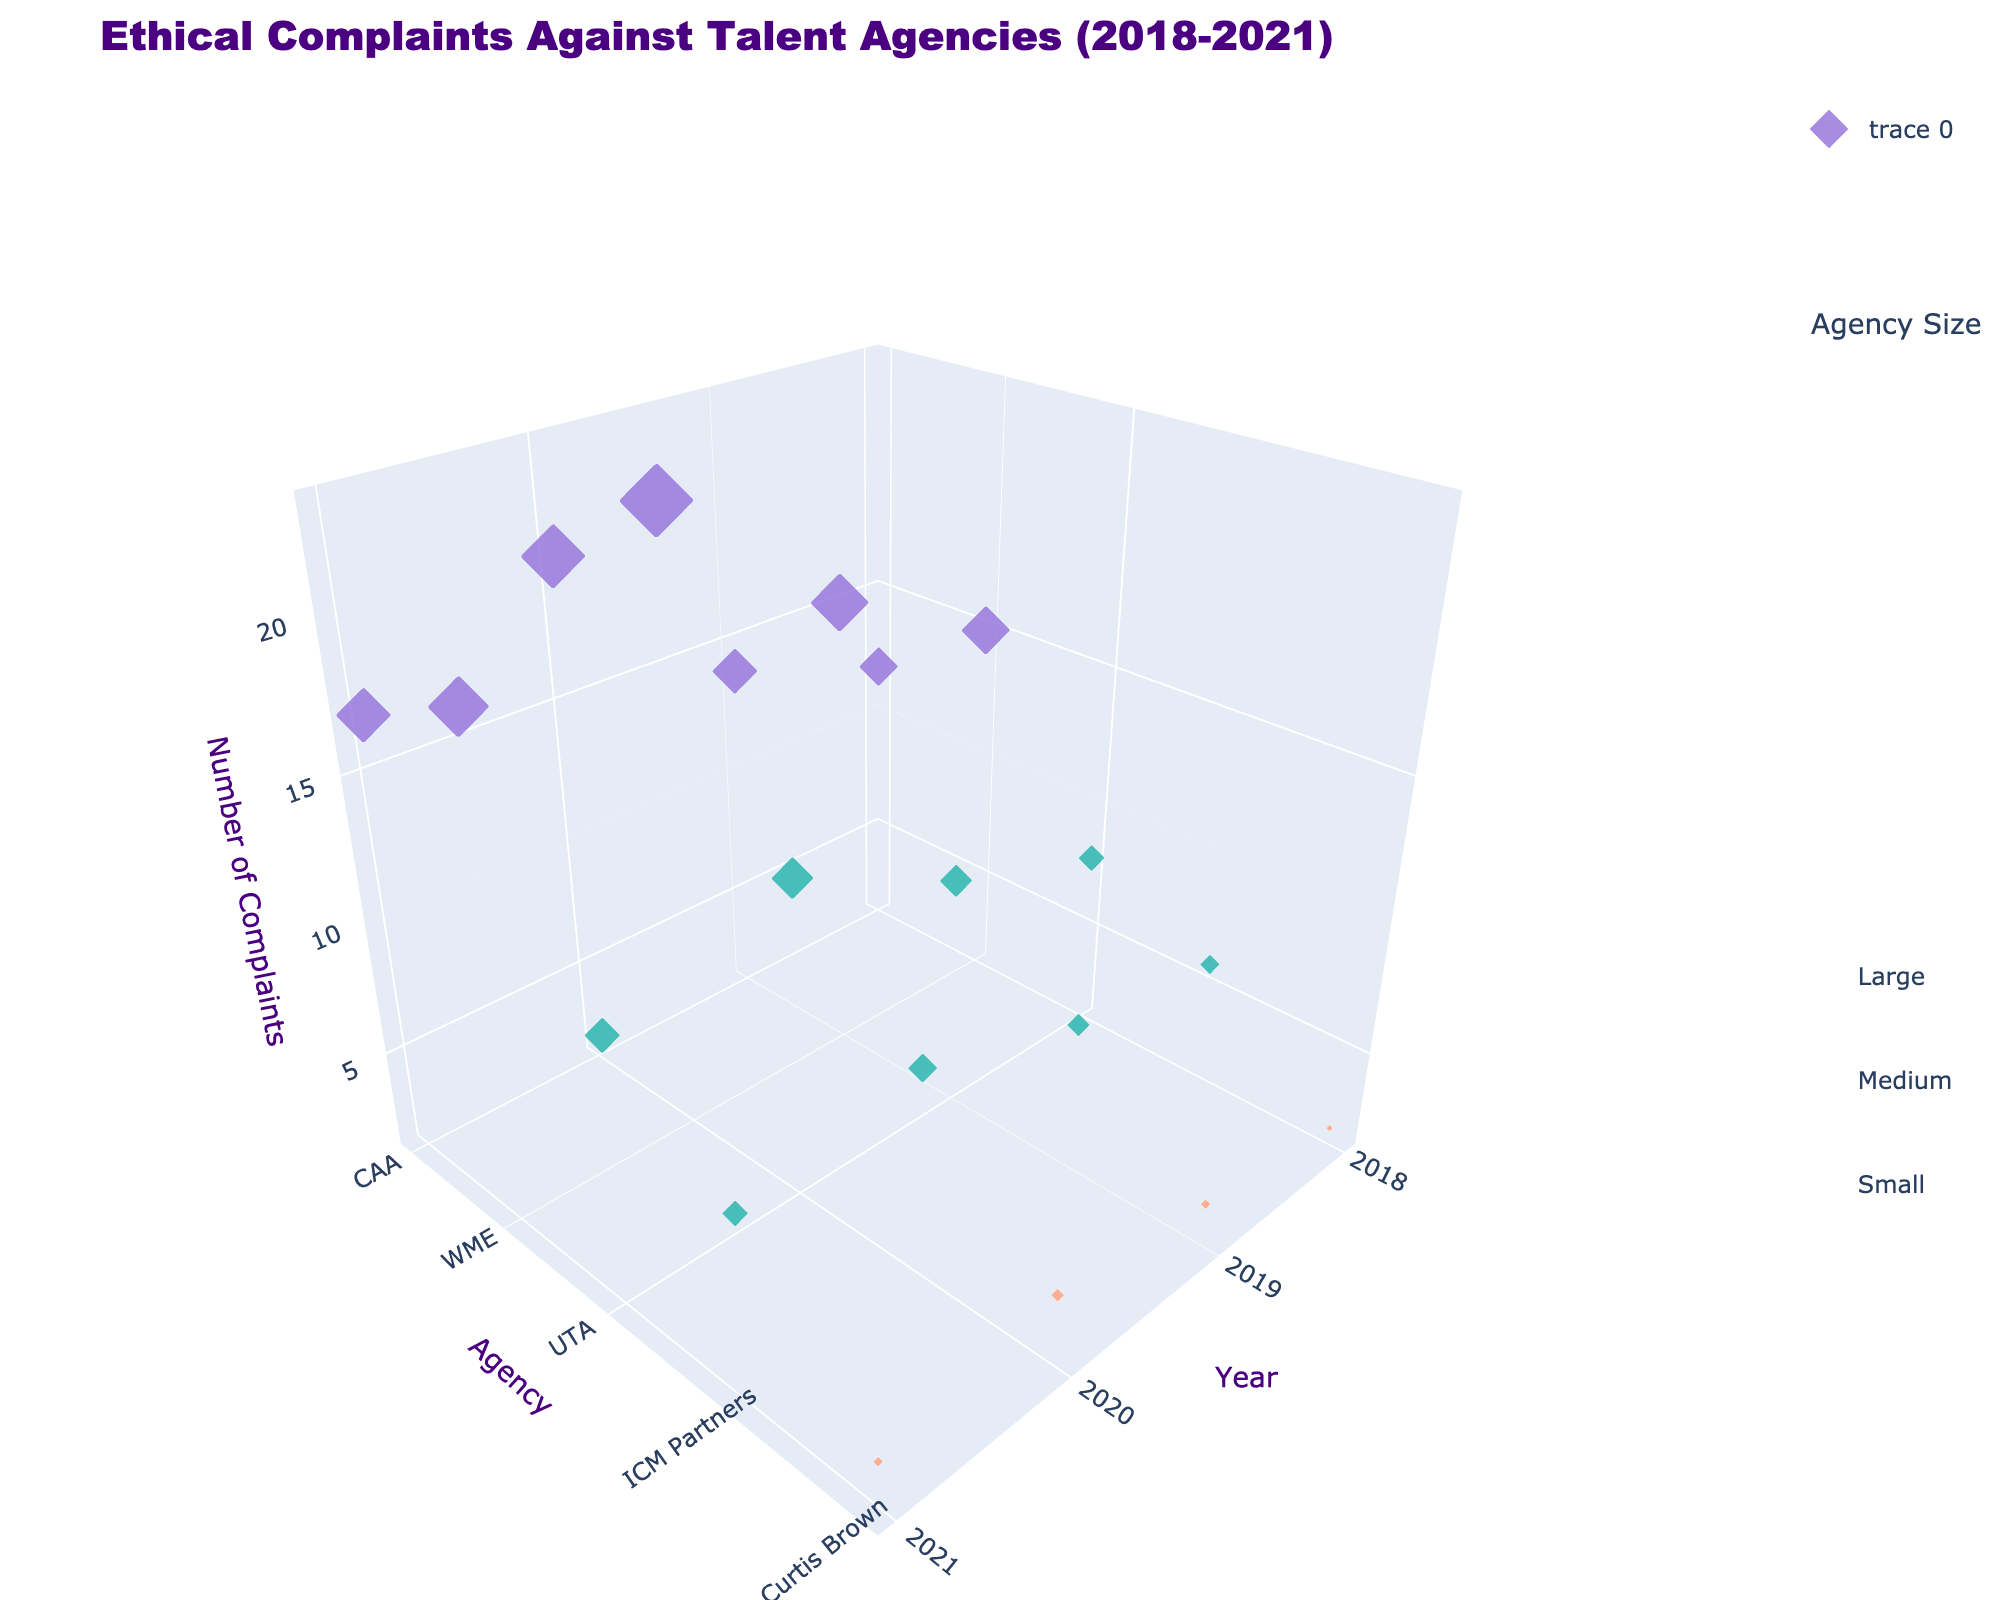What is the title of the figure? The title is typically positioned at the top of the plot and is clearly visible. In this figure, the title reads "Ethical Complaints Against Talent Agencies (2018-2021)"
Answer: Ethical Complaints Against Talent Agencies (2018-2021) Which year had the highest number of complaints for CAA? To find this, look at the markers representing CAA across the different years and identify the one with the highest z-value (Complaints). In 2020, CAA had the highest number of complaints with a value of 20.
Answer: 2020 Which agency is represented by the smallest markers? The size of the markers correlates with the number of complaints. Curtis Brown has the smallest markers, indicating the fewest complaints.
Answer: Curtis Brown What is the color representing medium-sized agencies? The color scheme is based on agency sizes: Small, Medium, and Large. The plot legend indicates that medium-sized agencies are represented by a turquoise color.
Answer: Turquoise How do the number of complaints for WME and UTA compare in 2019? Find the markers for WME and UTA for the year 2019 and compare their z-values. WME had 18 complaints, while UTA had 10 complaints in 2019.
Answer: WME had more complaints Which agency had the least increase in complaints from 2018 to 2020? Examine the difference in complaint numbers between 2020 and 2018 for each agency. Curtis Brown had an increase from 2 to 4 complaints, the smallest increase of 2 complaints.
Answer: Curtis Brown How does the geographical region influence the number of complaints? Inspect the regions denoted in the hover information and look for patterns. Agencies in North America show a higher number of complaints compared to the agency in Europe.
Answer: North American agencies had more complaints What trend is observed for large agencies over the years? Look at the markers for large agencies (CAA and WME) across the years and observe the change in z-values. They generally show an increasing trend in complaints until 2020, followed by a slight decrease in 2021.
Answer: Increasing until 2020, then slight decrease Calculate the average number of complaints for UTA across the four years. Sum up the complaints for UTA from 2018 to 2021 (8 + 10 + 13 + 11) and divide by 4. The average is 42 / 4 = 10.5.
Answer: 10.5 